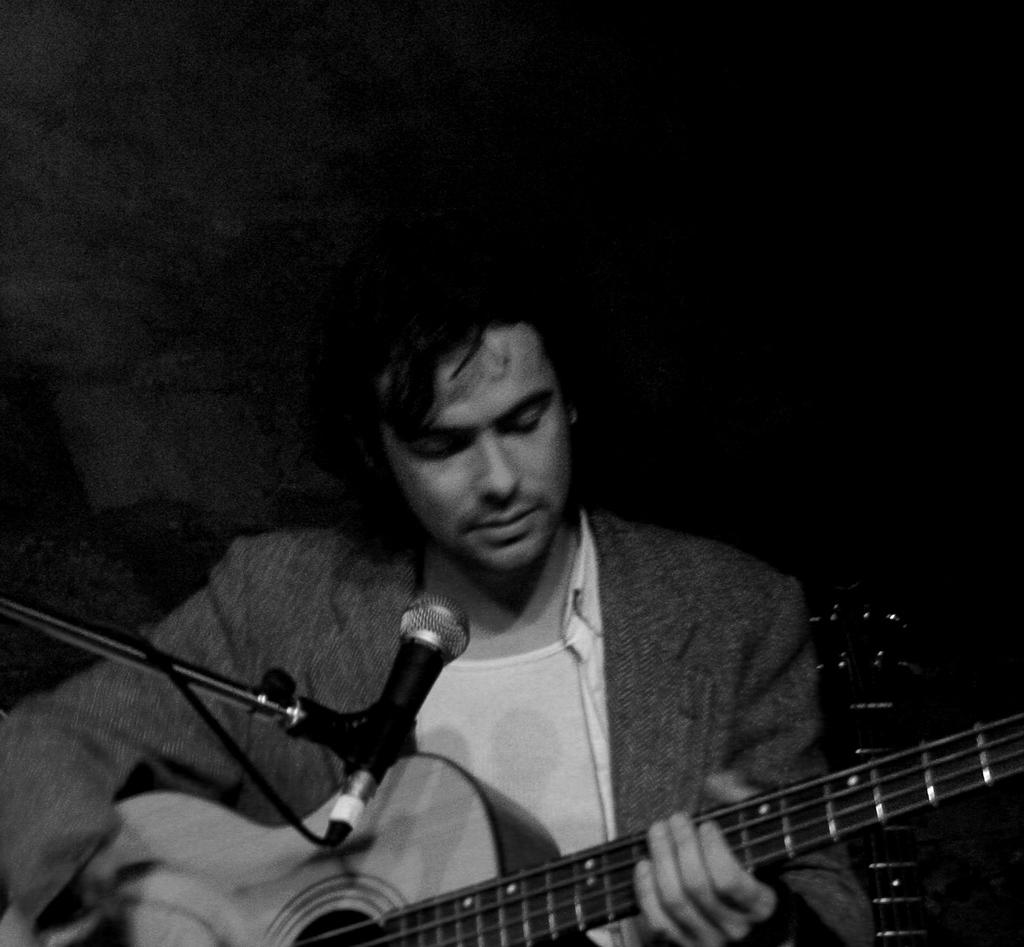Who or what is the main subject in the image? There is a person in the image. Can you describe the person's position in the image? The person is standing at the front side of the image. What is the person holding in his hand? The person is holding a guitar in his hand. What object is in front of the person? There is a microphone in front of the person. What type of egg is visible on the person's head in the image? There is no egg visible on the person's head in the image. What color are the person's lips in the image? The provided facts do not mention the person's lips, so we cannot determine their color from the image. 